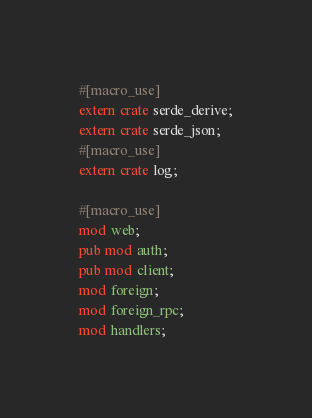Convert code to text. <code><loc_0><loc_0><loc_500><loc_500><_Rust_>
#[macro_use]
extern crate serde_derive;
extern crate serde_json;
#[macro_use]
extern crate log;

#[macro_use]
mod web;
pub mod auth;
pub mod client;
mod foreign;
mod foreign_rpc;
mod handlers;</code> 